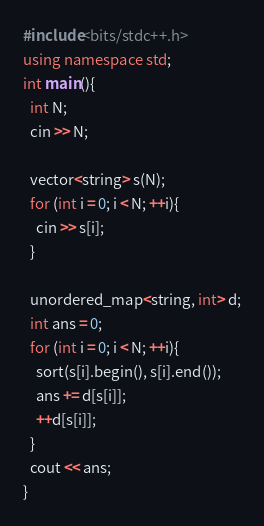Convert code to text. <code><loc_0><loc_0><loc_500><loc_500><_C++_>#include<bits/stdc++.h>
using namespace std;
int main(){
  int N;
  cin >> N;

  vector<string> s(N);
  for (int i = 0; i < N; ++i){
    cin >> s[i];
  }
  
  unordered_map<string, int> d;
  int ans = 0;
  for (int i = 0; i < N; ++i){
    sort(s[i].begin(), s[i].end());
    ans += d[s[i]];
    ++d[s[i]];
  }
  cout << ans;
}</code> 